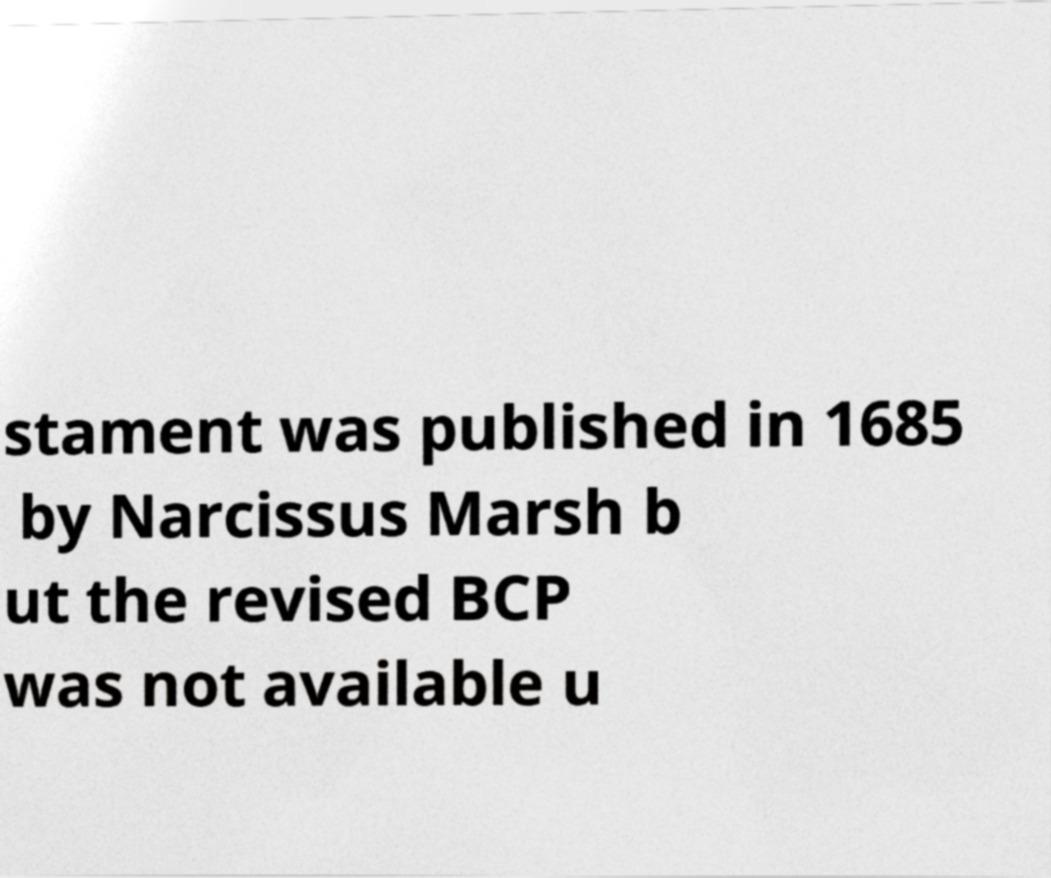Can you accurately transcribe the text from the provided image for me? stament was published in 1685 by Narcissus Marsh b ut the revised BCP was not available u 